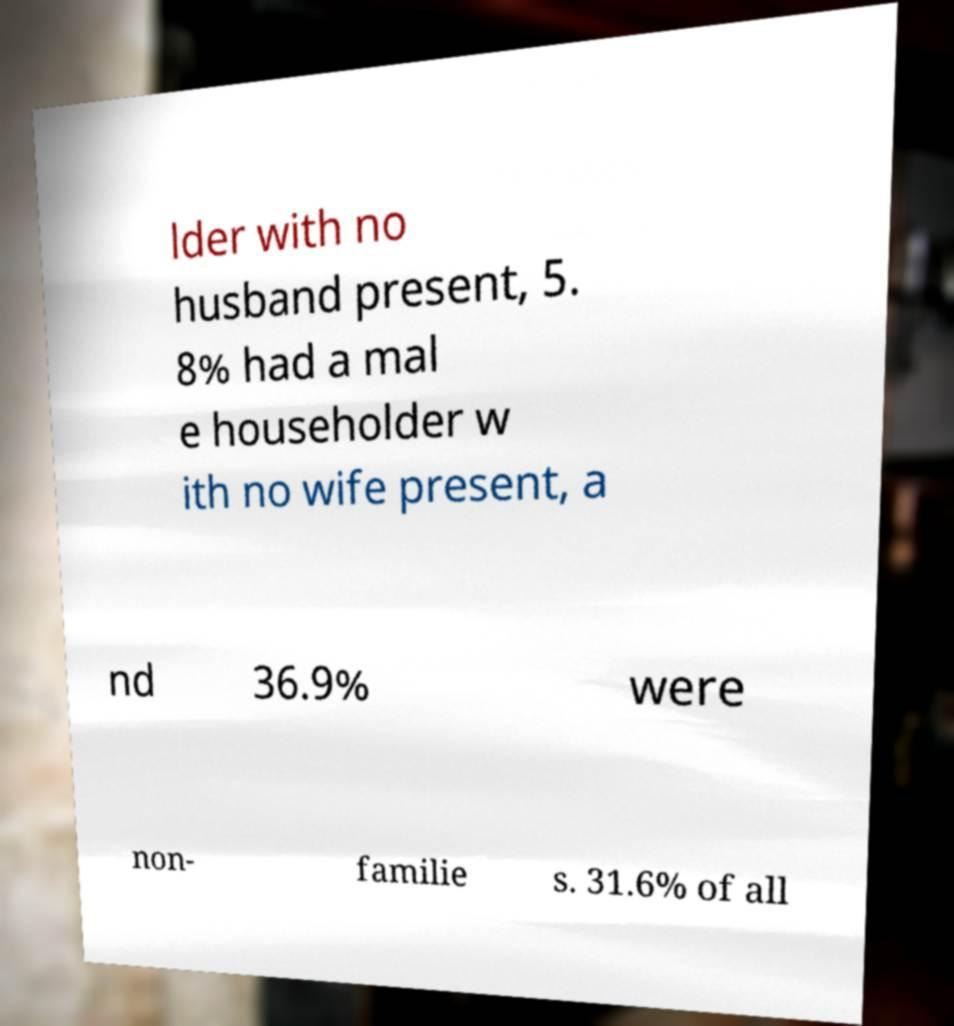For documentation purposes, I need the text within this image transcribed. Could you provide that? lder with no husband present, 5. 8% had a mal e householder w ith no wife present, a nd 36.9% were non- familie s. 31.6% of all 